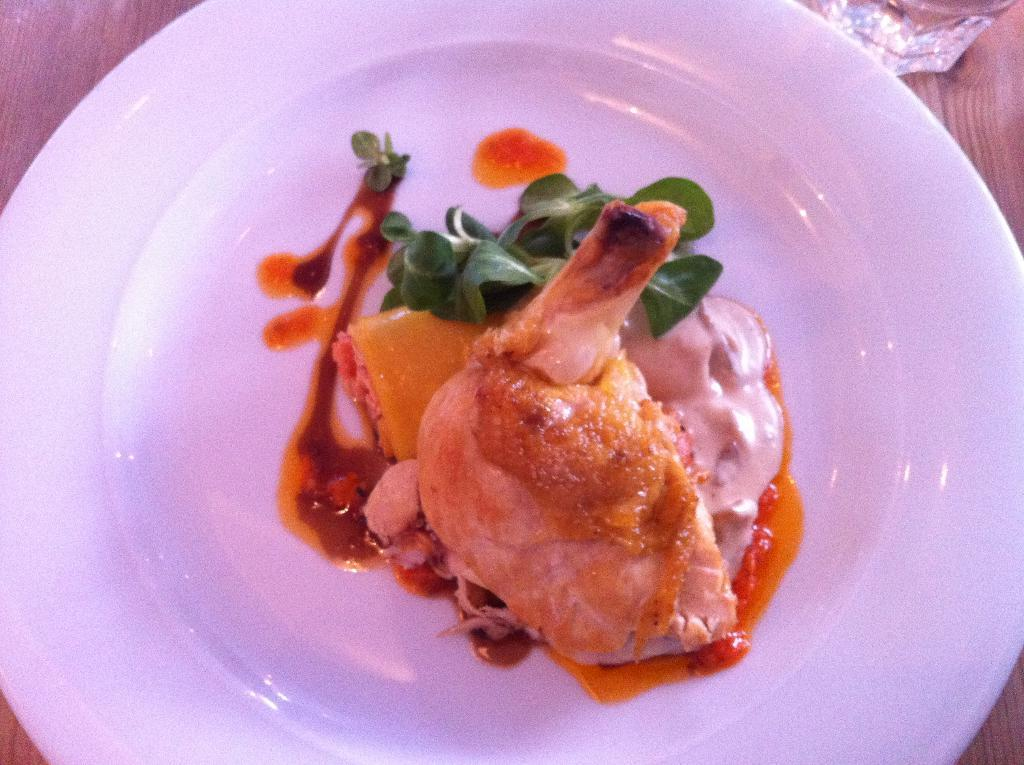What is the surface on which the plate is placed in the image? The plate is on a wooden surface in the image. What is the main food item on the plate? The food item on the plate has leaves, which suggests it might be a salad or a dish with leafy greens. Are there any other items on the plate besides the food item? Yes, there are other unspecified items on the plate. What is the weather like in the image? The provided facts do not mention anything about the weather, so it cannot be determined from the image. 